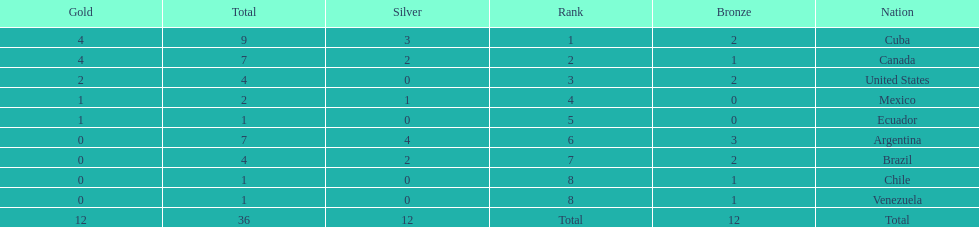Which countries won medals at the 2011 pan american games for the canoeing event? Cuba, Canada, United States, Mexico, Ecuador, Argentina, Brazil, Chile, Venezuela. Which of these countries won bronze medals? Cuba, Canada, United States, Argentina, Brazil, Chile, Venezuela. Of these countries, which won the most bronze medals? Argentina. 